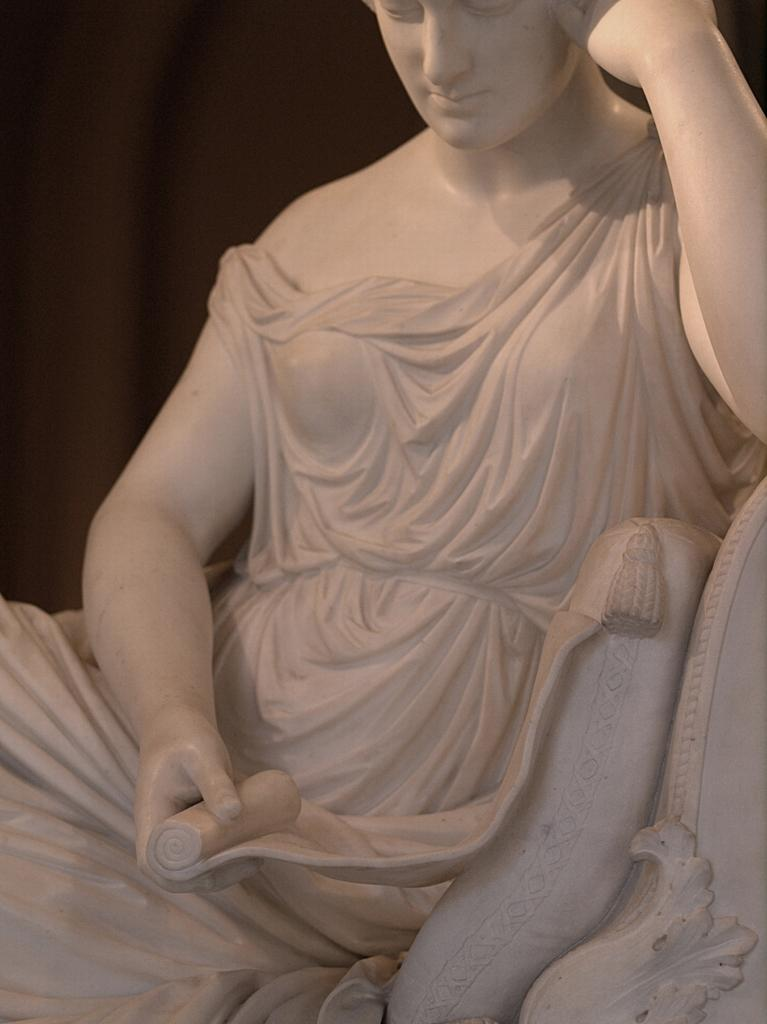What is the main subject of the image? There is a sculpture in the image. Can you describe the sculpture? The sculpture is of a person and is made of white stone. What type of treatment is the beetle receiving in the image? There is no beetle present in the image, and therefore no treatment can be observed. 